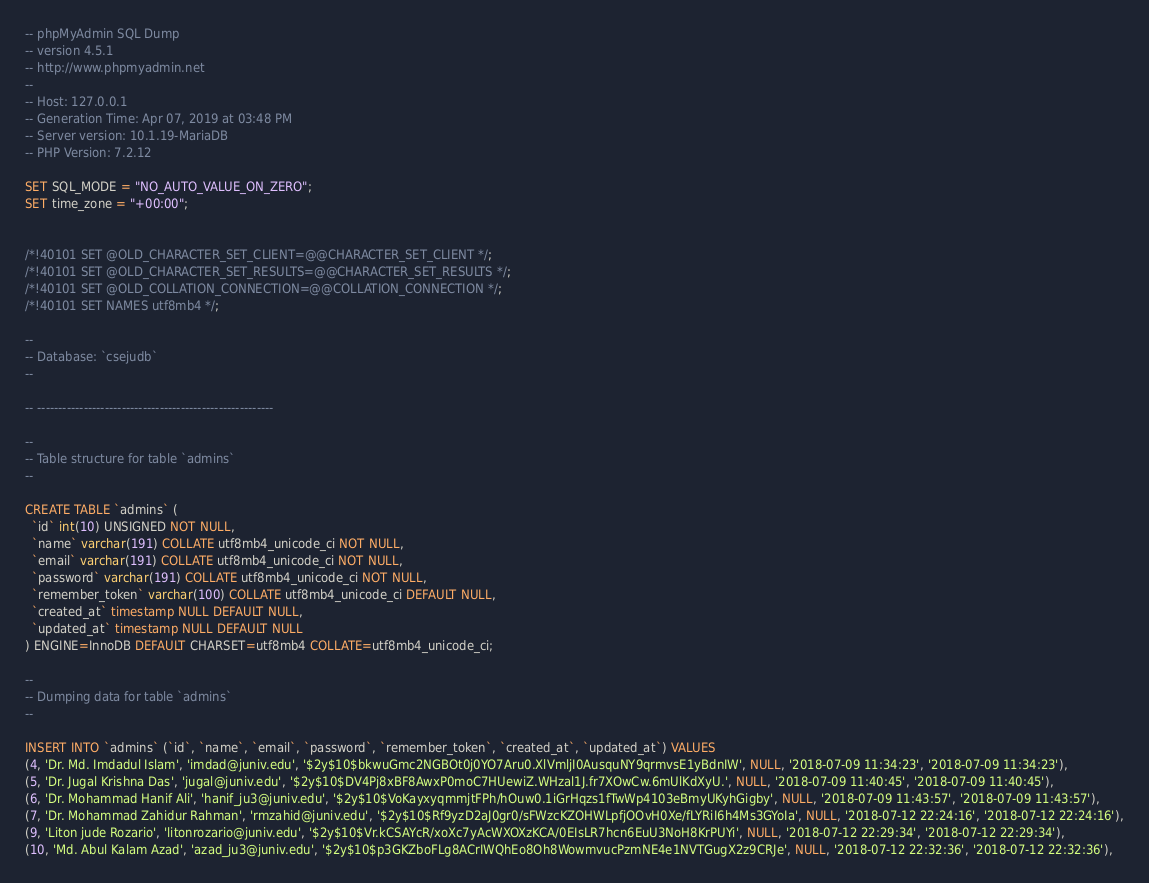Convert code to text. <code><loc_0><loc_0><loc_500><loc_500><_SQL_>-- phpMyAdmin SQL Dump
-- version 4.5.1
-- http://www.phpmyadmin.net
--
-- Host: 127.0.0.1
-- Generation Time: Apr 07, 2019 at 03:48 PM
-- Server version: 10.1.19-MariaDB
-- PHP Version: 7.2.12

SET SQL_MODE = "NO_AUTO_VALUE_ON_ZERO";
SET time_zone = "+00:00";


/*!40101 SET @OLD_CHARACTER_SET_CLIENT=@@CHARACTER_SET_CLIENT */;
/*!40101 SET @OLD_CHARACTER_SET_RESULTS=@@CHARACTER_SET_RESULTS */;
/*!40101 SET @OLD_COLLATION_CONNECTION=@@COLLATION_CONNECTION */;
/*!40101 SET NAMES utf8mb4 */;

--
-- Database: `csejudb`
--

-- --------------------------------------------------------

--
-- Table structure for table `admins`
--

CREATE TABLE `admins` (
  `id` int(10) UNSIGNED NOT NULL,
  `name` varchar(191) COLLATE utf8mb4_unicode_ci NOT NULL,
  `email` varchar(191) COLLATE utf8mb4_unicode_ci NOT NULL,
  `password` varchar(191) COLLATE utf8mb4_unicode_ci NOT NULL,
  `remember_token` varchar(100) COLLATE utf8mb4_unicode_ci DEFAULT NULL,
  `created_at` timestamp NULL DEFAULT NULL,
  `updated_at` timestamp NULL DEFAULT NULL
) ENGINE=InnoDB DEFAULT CHARSET=utf8mb4 COLLATE=utf8mb4_unicode_ci;

--
-- Dumping data for table `admins`
--

INSERT INTO `admins` (`id`, `name`, `email`, `password`, `remember_token`, `created_at`, `updated_at`) VALUES
(4, 'Dr. Md. Imdadul Islam', 'imdad@juniv.edu', '$2y$10$bkwuGmc2NGBOt0j0YO7Aru0.XlVmljI0AusquNY9qrmvsE1yBdnIW', NULL, '2018-07-09 11:34:23', '2018-07-09 11:34:23'),
(5, 'Dr. Jugal Krishna Das', 'jugal@juniv.edu', '$2y$10$DV4Pj8xBF8AwxP0moC7HUewiZ.WHzal1J.fr7XOwCw.6mUlKdXyU.', NULL, '2018-07-09 11:40:45', '2018-07-09 11:40:45'),
(6, 'Dr. Mohammad Hanif Ali', 'hanif_ju3@juniv.edu', '$2y$10$VoKayxyqmmjtFPh/hOuw0.1iGrHqzs1fTwWp4103eBmyUKyhGigby', NULL, '2018-07-09 11:43:57', '2018-07-09 11:43:57'),
(7, 'Dr. Mohammad Zahidur Rahman', 'rmzahid@juniv.edu', '$2y$10$Rf9yzD2aJ0gr0/sFWzcKZOHWLpfjOOvH0Xe/fLYRiI6h4Ms3GYoIa', NULL, '2018-07-12 22:24:16', '2018-07-12 22:24:16'),
(9, 'Liton jude Rozario', 'litonrozario@juniv.edu', '$2y$10$Vr.kCSAYcR/xoXc7yAcWXOXzKCA/0EIsLR7hcn6EuU3NoH8KrPUYi', NULL, '2018-07-12 22:29:34', '2018-07-12 22:29:34'),
(10, 'Md. Abul Kalam Azad', 'azad_ju3@juniv.edu', '$2y$10$p3GKZboFLg8ACrIWQhEo8Oh8WowmvucPzmNE4e1NVTGugX2z9CRJe', NULL, '2018-07-12 22:32:36', '2018-07-12 22:32:36'),</code> 